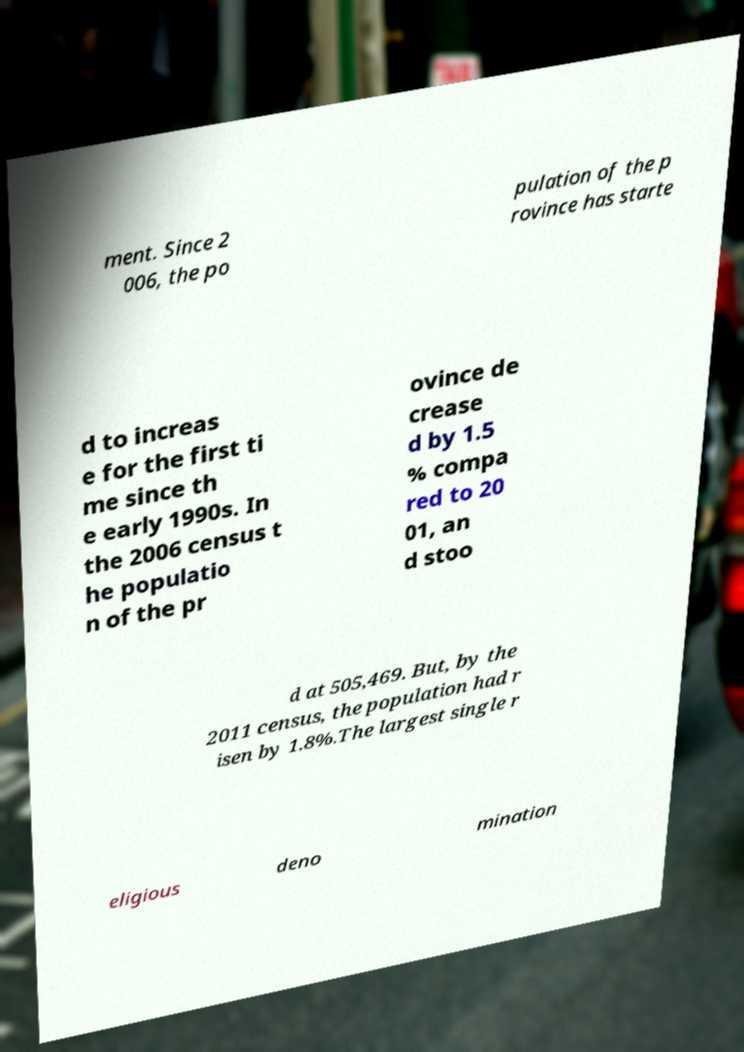I need the written content from this picture converted into text. Can you do that? ment. Since 2 006, the po pulation of the p rovince has starte d to increas e for the first ti me since th e early 1990s. In the 2006 census t he populatio n of the pr ovince de crease d by 1.5 % compa red to 20 01, an d stoo d at 505,469. But, by the 2011 census, the population had r isen by 1.8%.The largest single r eligious deno mination 